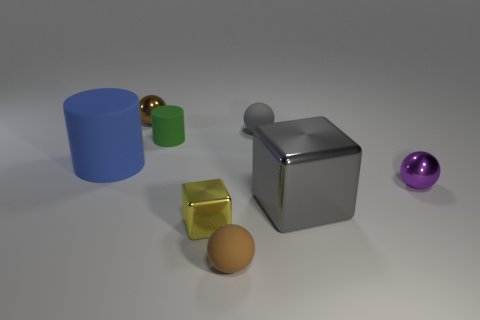Is the tiny gray thing the same shape as the large gray metallic object?
Offer a terse response. No. What color is the big shiny object?
Provide a short and direct response. Gray. What number of other objects are there of the same material as the green cylinder?
Provide a succinct answer. 3. What number of brown objects are large things or big matte cylinders?
Your answer should be very brief. 0. Do the metal thing that is to the right of the big cube and the yellow shiny thing that is left of the big gray thing have the same shape?
Provide a succinct answer. No. There is a small cylinder; is its color the same as the metallic block behind the small yellow block?
Give a very brief answer. No. Do the small metallic object on the right side of the yellow metallic block and the small block have the same color?
Give a very brief answer. No. How many objects are metal spheres or metal things in front of the gray shiny thing?
Keep it short and to the point. 3. There is a tiny thing that is both in front of the big metallic object and on the left side of the brown matte object; what is its material?
Keep it short and to the point. Metal. There is a big thing that is in front of the big cylinder; what is it made of?
Give a very brief answer. Metal. 